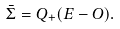Convert formula to latex. <formula><loc_0><loc_0><loc_500><loc_500>\bar { \Sigma } = Q _ { + } ( E - O ) .</formula> 